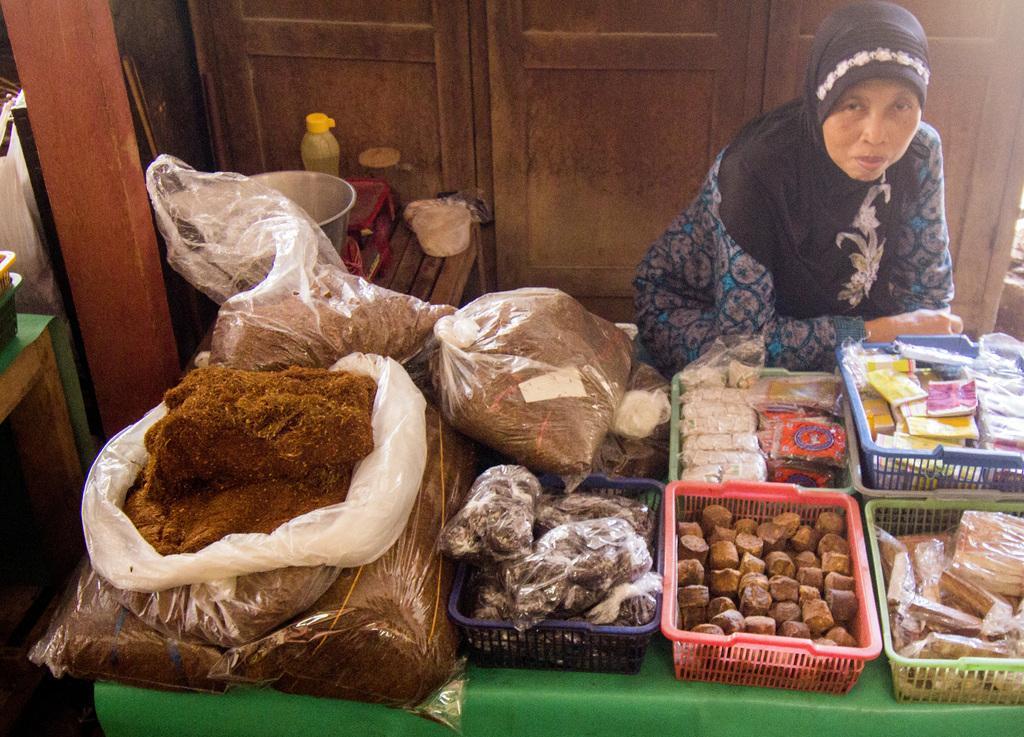Describe this image in one or two sentences. In this image we can see a woman sitting, in front of her we can see a table, on the table, we can see some baskets and cover bags with some objects, there are other tables with bottle, weight machine, boxes and some other things, in the background, it looks like a cupboard. 